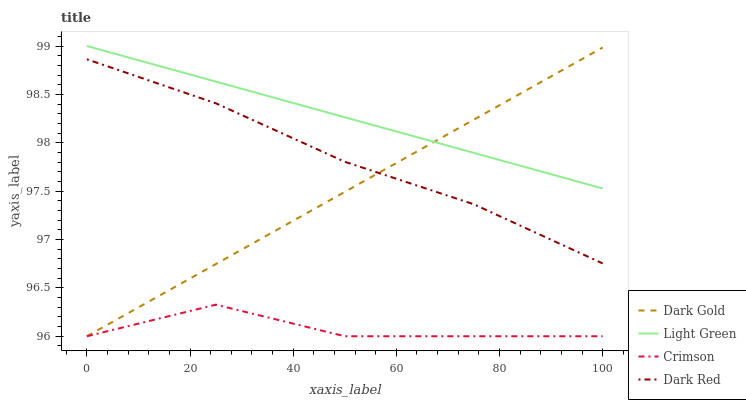Does Dark Red have the minimum area under the curve?
Answer yes or no. No. Does Dark Red have the maximum area under the curve?
Answer yes or no. No. Is Dark Red the smoothest?
Answer yes or no. No. Is Dark Red the roughest?
Answer yes or no. No. Does Dark Red have the lowest value?
Answer yes or no. No. Does Dark Red have the highest value?
Answer yes or no. No. Is Crimson less than Dark Red?
Answer yes or no. Yes. Is Light Green greater than Dark Red?
Answer yes or no. Yes. Does Crimson intersect Dark Red?
Answer yes or no. No. 